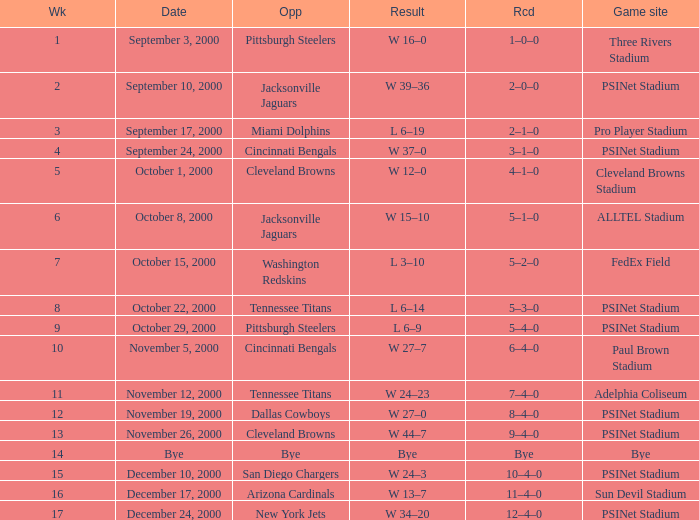What's the result at psinet stadium when the cincinnati bengals are the opponent? W 37–0. 